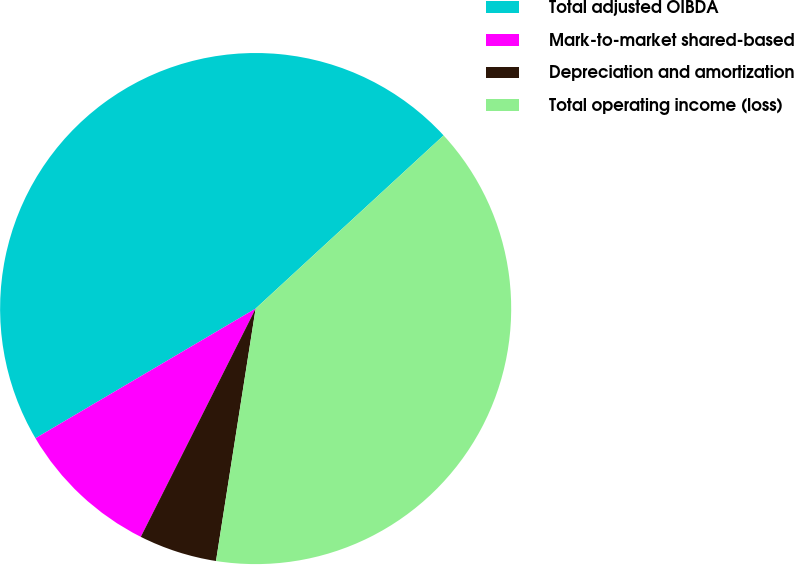Convert chart to OTSL. <chart><loc_0><loc_0><loc_500><loc_500><pie_chart><fcel>Total adjusted OIBDA<fcel>Mark-to-market shared-based<fcel>Depreciation and amortization<fcel>Total operating income (loss)<nl><fcel>46.63%<fcel>9.11%<fcel>4.94%<fcel>39.33%<nl></chart> 